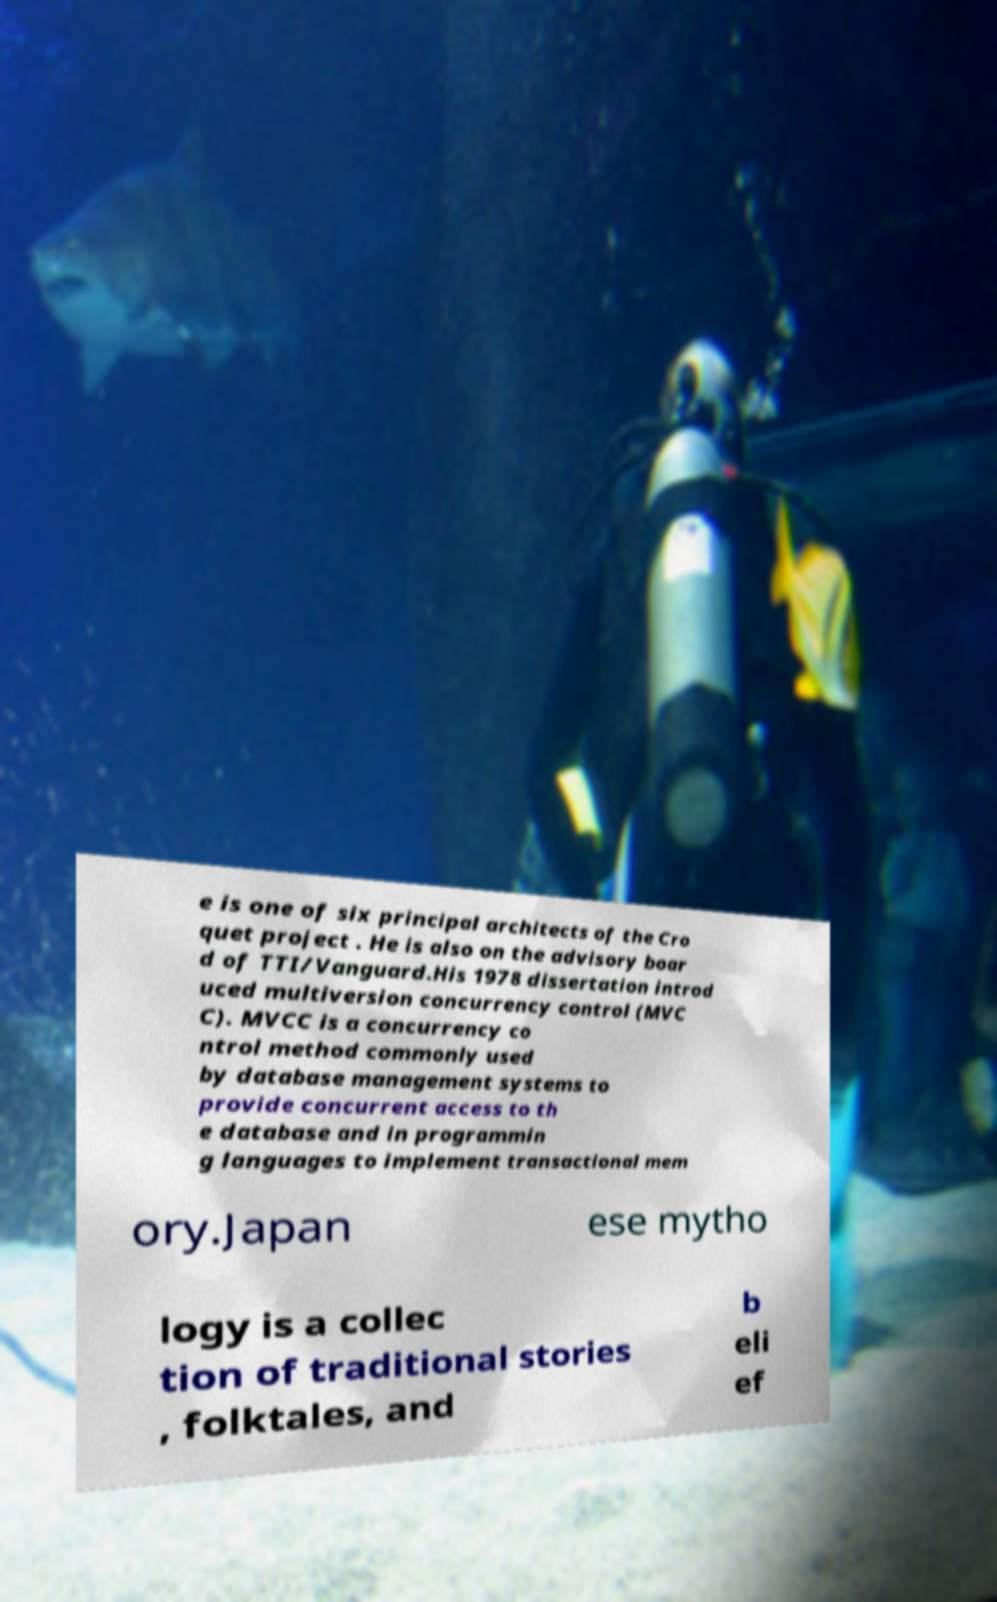What messages or text are displayed in this image? I need them in a readable, typed format. e is one of six principal architects of the Cro quet project . He is also on the advisory boar d of TTI/Vanguard.His 1978 dissertation introd uced multiversion concurrency control (MVC C). MVCC is a concurrency co ntrol method commonly used by database management systems to provide concurrent access to th e database and in programmin g languages to implement transactional mem ory.Japan ese mytho logy is a collec tion of traditional stories , folktales, and b eli ef 